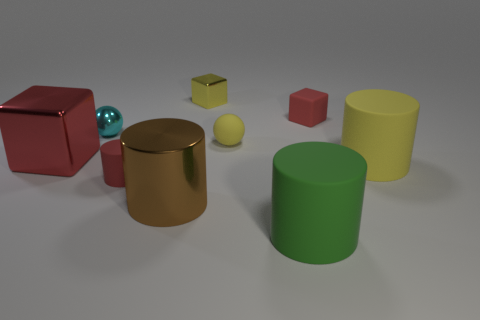Subtract 1 cylinders. How many cylinders are left? 3 Subtract all cylinders. How many objects are left? 5 Subtract 0 green balls. How many objects are left? 9 Subtract all small rubber cylinders. Subtract all brown cylinders. How many objects are left? 7 Add 7 yellow rubber cylinders. How many yellow rubber cylinders are left? 8 Add 4 small yellow things. How many small yellow things exist? 6 